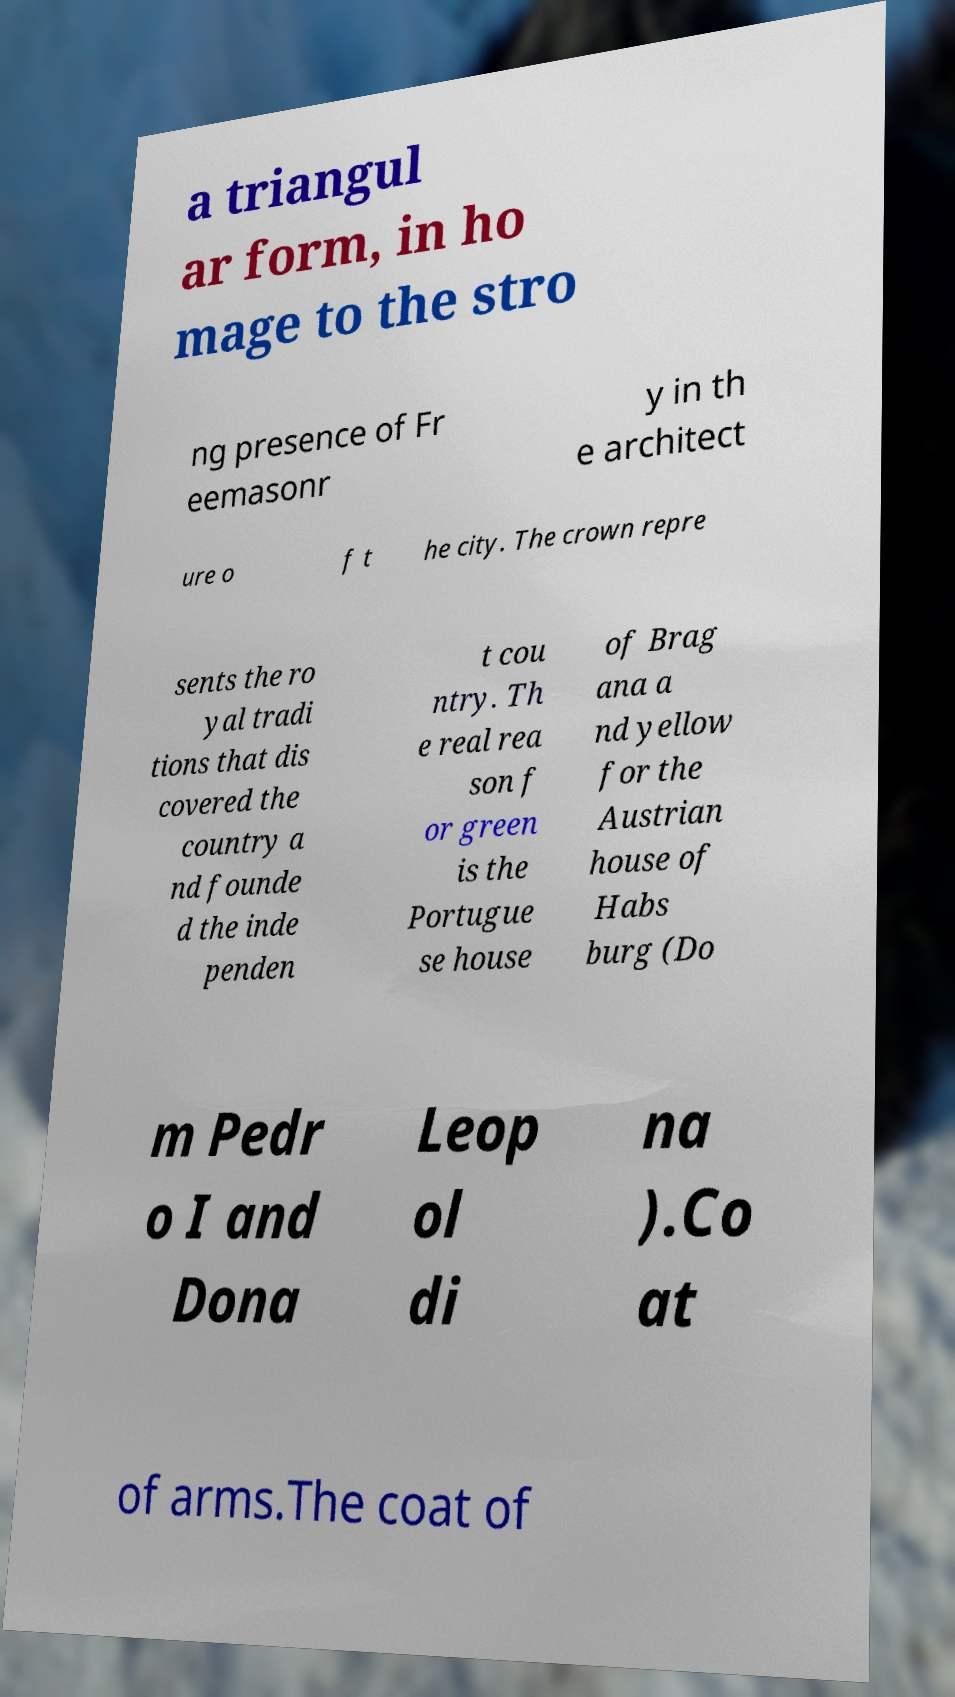There's text embedded in this image that I need extracted. Can you transcribe it verbatim? a triangul ar form, in ho mage to the stro ng presence of Fr eemasonr y in th e architect ure o f t he city. The crown repre sents the ro yal tradi tions that dis covered the country a nd founde d the inde penden t cou ntry. Th e real rea son f or green is the Portugue se house of Brag ana a nd yellow for the Austrian house of Habs burg (Do m Pedr o I and Dona Leop ol di na ).Co at of arms.The coat of 